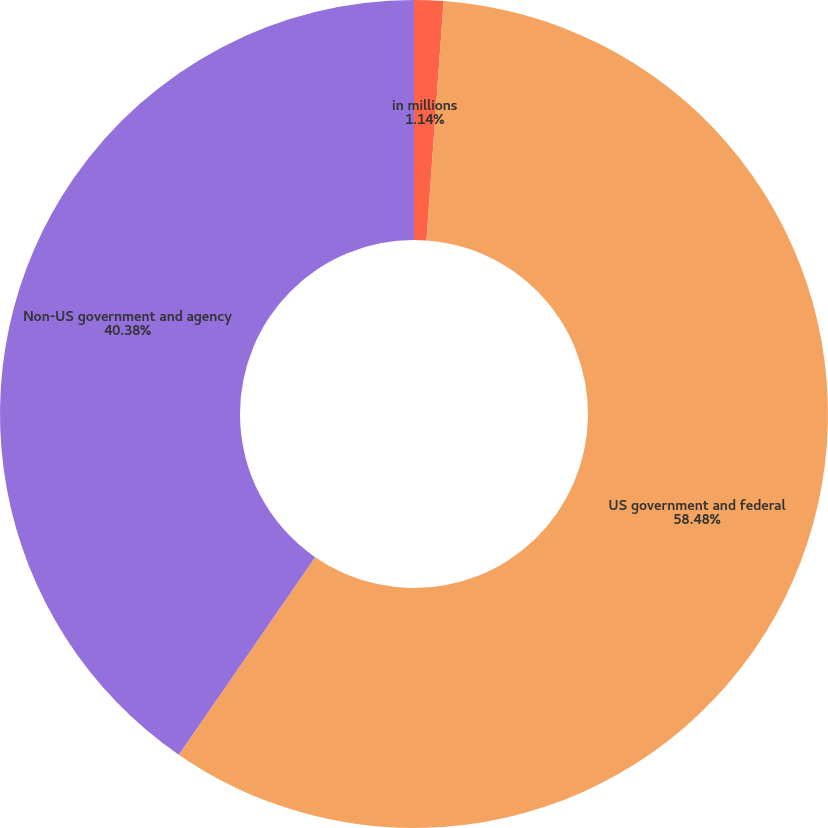Convert chart. <chart><loc_0><loc_0><loc_500><loc_500><pie_chart><fcel>in millions<fcel>US government and federal<fcel>Non-US government and agency<nl><fcel>1.14%<fcel>58.48%<fcel>40.38%<nl></chart> 